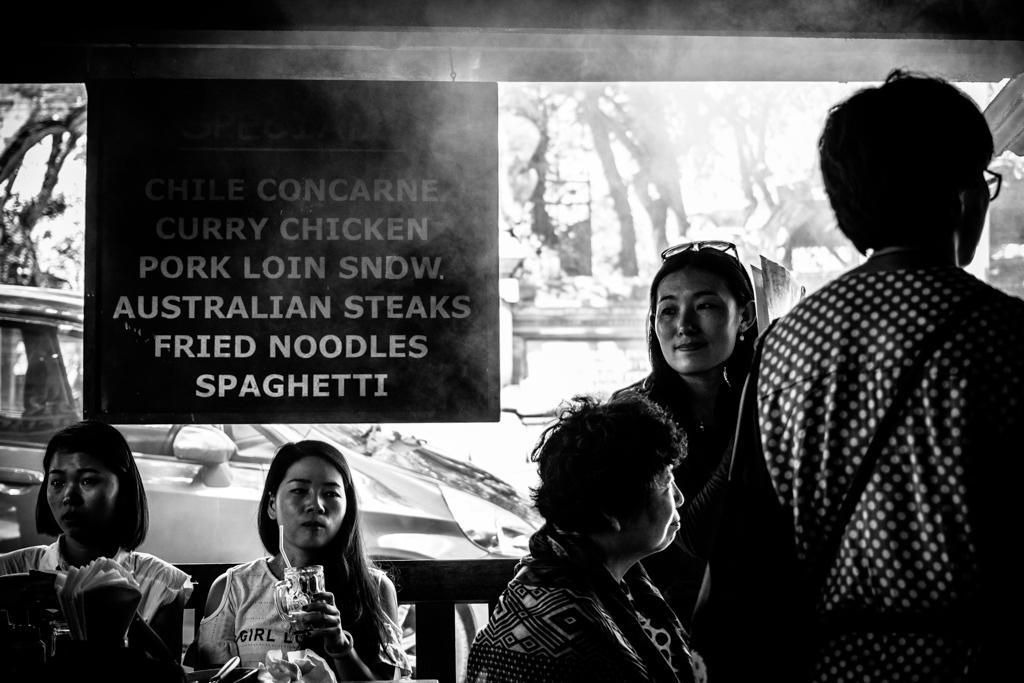Please provide a concise description of this image. In this image we can see persons sitting and standing on the floor, information board, motor vehicles, paper napkins, trees and sky. 